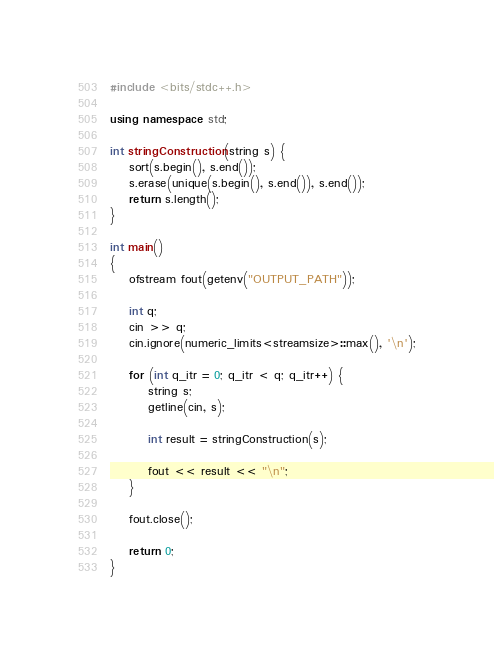Convert code to text. <code><loc_0><loc_0><loc_500><loc_500><_C++_>#include <bits/stdc++.h>

using namespace std;

int stringConstruction(string s) {
    sort(s.begin(), s.end());
    s.erase(unique(s.begin(), s.end()), s.end());
    return s.length();
}

int main()
{
    ofstream fout(getenv("OUTPUT_PATH"));

    int q;
    cin >> q;
    cin.ignore(numeric_limits<streamsize>::max(), '\n');

    for (int q_itr = 0; q_itr < q; q_itr++) {
        string s;
        getline(cin, s);

        int result = stringConstruction(s);

        fout << result << "\n";
    }

    fout.close();

    return 0;
}
</code> 